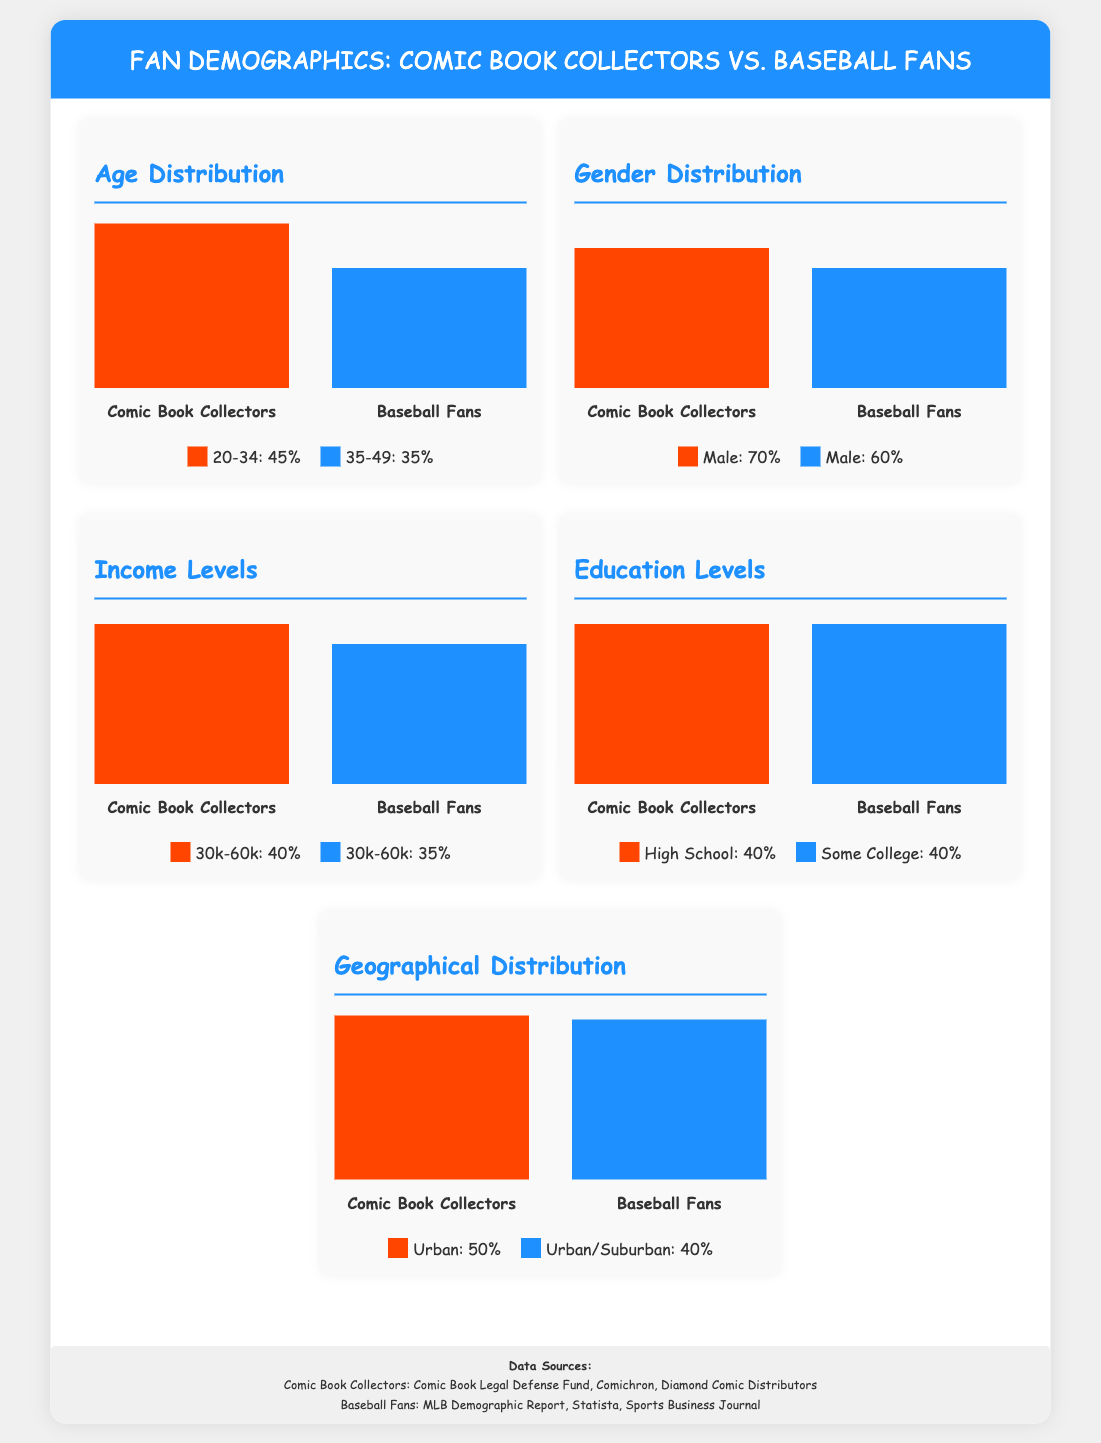What percentage of comic book collectors are aged 20-34? The document shows that 45% of comic book collectors fall within the 20-34 age range.
Answer: 45% What is the male percentage among baseball fans? The infographic states that 60% of baseball fans are male.
Answer: 60% How many income levels are shown in the infographic? The document mentions one income level, which is 30k-60k, represented for both comic book collectors and baseball fans.
Answer: One What is the height of the bar representing comic book collectors' education levels? The bar for comic book collectors' education levels is at 80%.
Answer: 80% Which fan demographic has a higher geographical distribution? The infographic indicates that comic book collectors have a 100% geographical distribution.
Answer: Comic Book Collectors What percentage of comic book collectors hold a high school education? The document indicates that 40% of comic book collectors have a high school education.
Answer: 40% What is the income percentage range for comic book collectors earning between 30k to 60k? The document states that 40% of comic book collectors fall into the income range of 30k-60k.
Answer: 40% Which fan group's age demographic is more diverse, comic book collectors or baseball fans? The infographic shows a greater percentage of comic book collectors (45% vs. 35%) in the younger age bracket, indicating higher diversity.
Answer: Comic Book Collectors What format is used for the document? The structure of the information presented adheres to an infographic style.
Answer: Infographic 